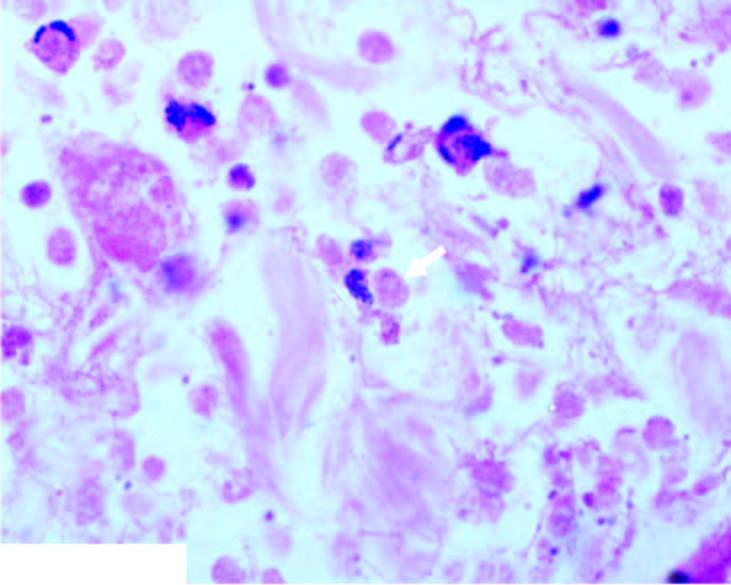does infarcted area show necrotic debris, acute inflammatory infiltrate and a few trophozoites of entamoeba histolytica?
Answer the question using a single word or phrase. No 